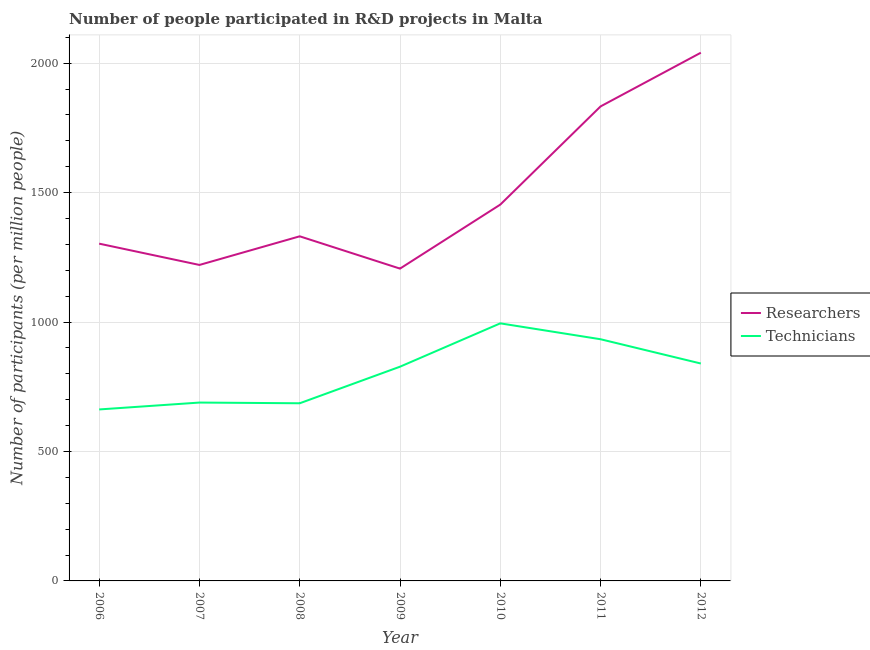Does the line corresponding to number of researchers intersect with the line corresponding to number of technicians?
Your answer should be compact. No. What is the number of technicians in 2010?
Your response must be concise. 994.99. Across all years, what is the maximum number of researchers?
Make the answer very short. 2040.44. Across all years, what is the minimum number of researchers?
Offer a very short reply. 1206.42. In which year was the number of technicians maximum?
Keep it short and to the point. 2010. In which year was the number of technicians minimum?
Offer a very short reply. 2006. What is the total number of researchers in the graph?
Give a very brief answer. 1.04e+04. What is the difference between the number of technicians in 2010 and that in 2012?
Your answer should be very brief. 155.15. What is the difference between the number of technicians in 2012 and the number of researchers in 2009?
Make the answer very short. -366.58. What is the average number of technicians per year?
Keep it short and to the point. 804.8. In the year 2008, what is the difference between the number of researchers and number of technicians?
Your response must be concise. 644.98. What is the ratio of the number of technicians in 2007 to that in 2011?
Offer a very short reply. 0.74. Is the number of researchers in 2006 less than that in 2010?
Your answer should be compact. Yes. Is the difference between the number of technicians in 2007 and 2009 greater than the difference between the number of researchers in 2007 and 2009?
Your answer should be compact. No. What is the difference between the highest and the second highest number of researchers?
Keep it short and to the point. 207.44. What is the difference between the highest and the lowest number of researchers?
Give a very brief answer. 834.02. Is the number of researchers strictly greater than the number of technicians over the years?
Provide a short and direct response. Yes. How many years are there in the graph?
Provide a succinct answer. 7. Are the values on the major ticks of Y-axis written in scientific E-notation?
Ensure brevity in your answer.  No. Does the graph contain any zero values?
Make the answer very short. No. Where does the legend appear in the graph?
Provide a succinct answer. Center right. What is the title of the graph?
Your answer should be compact. Number of people participated in R&D projects in Malta. Does "Quality of trade" appear as one of the legend labels in the graph?
Keep it short and to the point. No. What is the label or title of the X-axis?
Provide a short and direct response. Year. What is the label or title of the Y-axis?
Give a very brief answer. Number of participants (per million people). What is the Number of participants (per million people) in Researchers in 2006?
Offer a very short reply. 1302.85. What is the Number of participants (per million people) of Technicians in 2006?
Offer a very short reply. 662.41. What is the Number of participants (per million people) in Researchers in 2007?
Give a very brief answer. 1220.61. What is the Number of participants (per million people) of Technicians in 2007?
Your response must be concise. 688.99. What is the Number of participants (per million people) in Researchers in 2008?
Your response must be concise. 1331.23. What is the Number of participants (per million people) of Technicians in 2008?
Offer a terse response. 686.24. What is the Number of participants (per million people) of Researchers in 2009?
Provide a short and direct response. 1206.42. What is the Number of participants (per million people) of Technicians in 2009?
Give a very brief answer. 827.54. What is the Number of participants (per million people) in Researchers in 2010?
Offer a terse response. 1453.66. What is the Number of participants (per million people) in Technicians in 2010?
Provide a succinct answer. 994.99. What is the Number of participants (per million people) of Researchers in 2011?
Ensure brevity in your answer.  1833. What is the Number of participants (per million people) of Technicians in 2011?
Keep it short and to the point. 933.6. What is the Number of participants (per million people) in Researchers in 2012?
Make the answer very short. 2040.44. What is the Number of participants (per million people) of Technicians in 2012?
Offer a very short reply. 839.84. Across all years, what is the maximum Number of participants (per million people) in Researchers?
Your answer should be compact. 2040.44. Across all years, what is the maximum Number of participants (per million people) of Technicians?
Provide a short and direct response. 994.99. Across all years, what is the minimum Number of participants (per million people) of Researchers?
Make the answer very short. 1206.42. Across all years, what is the minimum Number of participants (per million people) of Technicians?
Offer a terse response. 662.41. What is the total Number of participants (per million people) in Researchers in the graph?
Provide a short and direct response. 1.04e+04. What is the total Number of participants (per million people) of Technicians in the graph?
Your response must be concise. 5633.61. What is the difference between the Number of participants (per million people) of Researchers in 2006 and that in 2007?
Offer a very short reply. 82.24. What is the difference between the Number of participants (per million people) in Technicians in 2006 and that in 2007?
Ensure brevity in your answer.  -26.58. What is the difference between the Number of participants (per million people) of Researchers in 2006 and that in 2008?
Your answer should be very brief. -28.38. What is the difference between the Number of participants (per million people) in Technicians in 2006 and that in 2008?
Keep it short and to the point. -23.84. What is the difference between the Number of participants (per million people) of Researchers in 2006 and that in 2009?
Provide a succinct answer. 96.43. What is the difference between the Number of participants (per million people) in Technicians in 2006 and that in 2009?
Give a very brief answer. -165.14. What is the difference between the Number of participants (per million people) in Researchers in 2006 and that in 2010?
Ensure brevity in your answer.  -150.81. What is the difference between the Number of participants (per million people) of Technicians in 2006 and that in 2010?
Your response must be concise. -332.58. What is the difference between the Number of participants (per million people) in Researchers in 2006 and that in 2011?
Give a very brief answer. -530.15. What is the difference between the Number of participants (per million people) of Technicians in 2006 and that in 2011?
Your answer should be compact. -271.19. What is the difference between the Number of participants (per million people) of Researchers in 2006 and that in 2012?
Give a very brief answer. -737.59. What is the difference between the Number of participants (per million people) of Technicians in 2006 and that in 2012?
Your response must be concise. -177.43. What is the difference between the Number of participants (per million people) of Researchers in 2007 and that in 2008?
Keep it short and to the point. -110.61. What is the difference between the Number of participants (per million people) in Technicians in 2007 and that in 2008?
Offer a terse response. 2.75. What is the difference between the Number of participants (per million people) of Researchers in 2007 and that in 2009?
Your answer should be compact. 14.19. What is the difference between the Number of participants (per million people) of Technicians in 2007 and that in 2009?
Provide a succinct answer. -138.55. What is the difference between the Number of participants (per million people) of Researchers in 2007 and that in 2010?
Your answer should be compact. -233.04. What is the difference between the Number of participants (per million people) of Technicians in 2007 and that in 2010?
Your answer should be very brief. -306. What is the difference between the Number of participants (per million people) of Researchers in 2007 and that in 2011?
Provide a short and direct response. -612.39. What is the difference between the Number of participants (per million people) in Technicians in 2007 and that in 2011?
Provide a short and direct response. -244.61. What is the difference between the Number of participants (per million people) in Researchers in 2007 and that in 2012?
Ensure brevity in your answer.  -819.83. What is the difference between the Number of participants (per million people) in Technicians in 2007 and that in 2012?
Your response must be concise. -150.85. What is the difference between the Number of participants (per million people) in Researchers in 2008 and that in 2009?
Your answer should be compact. 124.8. What is the difference between the Number of participants (per million people) of Technicians in 2008 and that in 2009?
Your answer should be compact. -141.3. What is the difference between the Number of participants (per million people) in Researchers in 2008 and that in 2010?
Keep it short and to the point. -122.43. What is the difference between the Number of participants (per million people) in Technicians in 2008 and that in 2010?
Your answer should be very brief. -308.74. What is the difference between the Number of participants (per million people) of Researchers in 2008 and that in 2011?
Make the answer very short. -501.77. What is the difference between the Number of participants (per million people) of Technicians in 2008 and that in 2011?
Provide a succinct answer. -247.35. What is the difference between the Number of participants (per million people) of Researchers in 2008 and that in 2012?
Ensure brevity in your answer.  -709.22. What is the difference between the Number of participants (per million people) of Technicians in 2008 and that in 2012?
Keep it short and to the point. -153.59. What is the difference between the Number of participants (per million people) of Researchers in 2009 and that in 2010?
Ensure brevity in your answer.  -247.23. What is the difference between the Number of participants (per million people) of Technicians in 2009 and that in 2010?
Provide a short and direct response. -167.45. What is the difference between the Number of participants (per million people) of Researchers in 2009 and that in 2011?
Keep it short and to the point. -626.58. What is the difference between the Number of participants (per million people) in Technicians in 2009 and that in 2011?
Ensure brevity in your answer.  -106.06. What is the difference between the Number of participants (per million people) of Researchers in 2009 and that in 2012?
Your response must be concise. -834.02. What is the difference between the Number of participants (per million people) of Technicians in 2009 and that in 2012?
Offer a terse response. -12.3. What is the difference between the Number of participants (per million people) of Researchers in 2010 and that in 2011?
Offer a terse response. -379.34. What is the difference between the Number of participants (per million people) of Technicians in 2010 and that in 2011?
Make the answer very short. 61.39. What is the difference between the Number of participants (per million people) of Researchers in 2010 and that in 2012?
Your answer should be compact. -586.79. What is the difference between the Number of participants (per million people) in Technicians in 2010 and that in 2012?
Give a very brief answer. 155.15. What is the difference between the Number of participants (per million people) of Researchers in 2011 and that in 2012?
Provide a short and direct response. -207.44. What is the difference between the Number of participants (per million people) of Technicians in 2011 and that in 2012?
Your response must be concise. 93.76. What is the difference between the Number of participants (per million people) in Researchers in 2006 and the Number of participants (per million people) in Technicians in 2007?
Offer a terse response. 613.86. What is the difference between the Number of participants (per million people) of Researchers in 2006 and the Number of participants (per million people) of Technicians in 2008?
Provide a short and direct response. 616.61. What is the difference between the Number of participants (per million people) in Researchers in 2006 and the Number of participants (per million people) in Technicians in 2009?
Offer a very short reply. 475.31. What is the difference between the Number of participants (per million people) of Researchers in 2006 and the Number of participants (per million people) of Technicians in 2010?
Offer a terse response. 307.86. What is the difference between the Number of participants (per million people) of Researchers in 2006 and the Number of participants (per million people) of Technicians in 2011?
Your response must be concise. 369.25. What is the difference between the Number of participants (per million people) in Researchers in 2006 and the Number of participants (per million people) in Technicians in 2012?
Give a very brief answer. 463.01. What is the difference between the Number of participants (per million people) in Researchers in 2007 and the Number of participants (per million people) in Technicians in 2008?
Make the answer very short. 534.37. What is the difference between the Number of participants (per million people) in Researchers in 2007 and the Number of participants (per million people) in Technicians in 2009?
Your response must be concise. 393.07. What is the difference between the Number of participants (per million people) in Researchers in 2007 and the Number of participants (per million people) in Technicians in 2010?
Your answer should be compact. 225.62. What is the difference between the Number of participants (per million people) of Researchers in 2007 and the Number of participants (per million people) of Technicians in 2011?
Ensure brevity in your answer.  287.01. What is the difference between the Number of participants (per million people) in Researchers in 2007 and the Number of participants (per million people) in Technicians in 2012?
Your answer should be very brief. 380.78. What is the difference between the Number of participants (per million people) in Researchers in 2008 and the Number of participants (per million people) in Technicians in 2009?
Keep it short and to the point. 503.69. What is the difference between the Number of participants (per million people) in Researchers in 2008 and the Number of participants (per million people) in Technicians in 2010?
Provide a short and direct response. 336.24. What is the difference between the Number of participants (per million people) of Researchers in 2008 and the Number of participants (per million people) of Technicians in 2011?
Provide a short and direct response. 397.63. What is the difference between the Number of participants (per million people) in Researchers in 2008 and the Number of participants (per million people) in Technicians in 2012?
Your response must be concise. 491.39. What is the difference between the Number of participants (per million people) of Researchers in 2009 and the Number of participants (per million people) of Technicians in 2010?
Your answer should be compact. 211.43. What is the difference between the Number of participants (per million people) of Researchers in 2009 and the Number of participants (per million people) of Technicians in 2011?
Your answer should be very brief. 272.82. What is the difference between the Number of participants (per million people) of Researchers in 2009 and the Number of participants (per million people) of Technicians in 2012?
Your response must be concise. 366.58. What is the difference between the Number of participants (per million people) of Researchers in 2010 and the Number of participants (per million people) of Technicians in 2011?
Offer a terse response. 520.06. What is the difference between the Number of participants (per million people) of Researchers in 2010 and the Number of participants (per million people) of Technicians in 2012?
Give a very brief answer. 613.82. What is the difference between the Number of participants (per million people) of Researchers in 2011 and the Number of participants (per million people) of Technicians in 2012?
Your response must be concise. 993.16. What is the average Number of participants (per million people) of Researchers per year?
Keep it short and to the point. 1484.03. What is the average Number of participants (per million people) in Technicians per year?
Give a very brief answer. 804.8. In the year 2006, what is the difference between the Number of participants (per million people) of Researchers and Number of participants (per million people) of Technicians?
Give a very brief answer. 640.45. In the year 2007, what is the difference between the Number of participants (per million people) of Researchers and Number of participants (per million people) of Technicians?
Your response must be concise. 531.62. In the year 2008, what is the difference between the Number of participants (per million people) in Researchers and Number of participants (per million people) in Technicians?
Offer a terse response. 644.98. In the year 2009, what is the difference between the Number of participants (per million people) of Researchers and Number of participants (per million people) of Technicians?
Make the answer very short. 378.88. In the year 2010, what is the difference between the Number of participants (per million people) of Researchers and Number of participants (per million people) of Technicians?
Your response must be concise. 458.67. In the year 2011, what is the difference between the Number of participants (per million people) of Researchers and Number of participants (per million people) of Technicians?
Your answer should be very brief. 899.4. In the year 2012, what is the difference between the Number of participants (per million people) of Researchers and Number of participants (per million people) of Technicians?
Your answer should be compact. 1200.61. What is the ratio of the Number of participants (per million people) of Researchers in 2006 to that in 2007?
Your answer should be compact. 1.07. What is the ratio of the Number of participants (per million people) in Technicians in 2006 to that in 2007?
Your response must be concise. 0.96. What is the ratio of the Number of participants (per million people) of Researchers in 2006 to that in 2008?
Your response must be concise. 0.98. What is the ratio of the Number of participants (per million people) in Technicians in 2006 to that in 2008?
Give a very brief answer. 0.97. What is the ratio of the Number of participants (per million people) in Researchers in 2006 to that in 2009?
Make the answer very short. 1.08. What is the ratio of the Number of participants (per million people) in Technicians in 2006 to that in 2009?
Offer a very short reply. 0.8. What is the ratio of the Number of participants (per million people) in Researchers in 2006 to that in 2010?
Make the answer very short. 0.9. What is the ratio of the Number of participants (per million people) in Technicians in 2006 to that in 2010?
Provide a succinct answer. 0.67. What is the ratio of the Number of participants (per million people) in Researchers in 2006 to that in 2011?
Your answer should be very brief. 0.71. What is the ratio of the Number of participants (per million people) of Technicians in 2006 to that in 2011?
Keep it short and to the point. 0.71. What is the ratio of the Number of participants (per million people) in Researchers in 2006 to that in 2012?
Your answer should be compact. 0.64. What is the ratio of the Number of participants (per million people) of Technicians in 2006 to that in 2012?
Keep it short and to the point. 0.79. What is the ratio of the Number of participants (per million people) in Researchers in 2007 to that in 2008?
Make the answer very short. 0.92. What is the ratio of the Number of participants (per million people) in Researchers in 2007 to that in 2009?
Give a very brief answer. 1.01. What is the ratio of the Number of participants (per million people) in Technicians in 2007 to that in 2009?
Offer a terse response. 0.83. What is the ratio of the Number of participants (per million people) of Researchers in 2007 to that in 2010?
Ensure brevity in your answer.  0.84. What is the ratio of the Number of participants (per million people) of Technicians in 2007 to that in 2010?
Give a very brief answer. 0.69. What is the ratio of the Number of participants (per million people) in Researchers in 2007 to that in 2011?
Keep it short and to the point. 0.67. What is the ratio of the Number of participants (per million people) of Technicians in 2007 to that in 2011?
Keep it short and to the point. 0.74. What is the ratio of the Number of participants (per million people) in Researchers in 2007 to that in 2012?
Provide a succinct answer. 0.6. What is the ratio of the Number of participants (per million people) of Technicians in 2007 to that in 2012?
Give a very brief answer. 0.82. What is the ratio of the Number of participants (per million people) of Researchers in 2008 to that in 2009?
Provide a short and direct response. 1.1. What is the ratio of the Number of participants (per million people) of Technicians in 2008 to that in 2009?
Keep it short and to the point. 0.83. What is the ratio of the Number of participants (per million people) of Researchers in 2008 to that in 2010?
Keep it short and to the point. 0.92. What is the ratio of the Number of participants (per million people) of Technicians in 2008 to that in 2010?
Offer a very short reply. 0.69. What is the ratio of the Number of participants (per million people) in Researchers in 2008 to that in 2011?
Give a very brief answer. 0.73. What is the ratio of the Number of participants (per million people) in Technicians in 2008 to that in 2011?
Keep it short and to the point. 0.74. What is the ratio of the Number of participants (per million people) of Researchers in 2008 to that in 2012?
Keep it short and to the point. 0.65. What is the ratio of the Number of participants (per million people) in Technicians in 2008 to that in 2012?
Make the answer very short. 0.82. What is the ratio of the Number of participants (per million people) of Researchers in 2009 to that in 2010?
Offer a terse response. 0.83. What is the ratio of the Number of participants (per million people) of Technicians in 2009 to that in 2010?
Ensure brevity in your answer.  0.83. What is the ratio of the Number of participants (per million people) in Researchers in 2009 to that in 2011?
Give a very brief answer. 0.66. What is the ratio of the Number of participants (per million people) in Technicians in 2009 to that in 2011?
Make the answer very short. 0.89. What is the ratio of the Number of participants (per million people) in Researchers in 2009 to that in 2012?
Offer a very short reply. 0.59. What is the ratio of the Number of participants (per million people) in Technicians in 2009 to that in 2012?
Make the answer very short. 0.99. What is the ratio of the Number of participants (per million people) in Researchers in 2010 to that in 2011?
Offer a terse response. 0.79. What is the ratio of the Number of participants (per million people) of Technicians in 2010 to that in 2011?
Provide a short and direct response. 1.07. What is the ratio of the Number of participants (per million people) in Researchers in 2010 to that in 2012?
Ensure brevity in your answer.  0.71. What is the ratio of the Number of participants (per million people) of Technicians in 2010 to that in 2012?
Your answer should be compact. 1.18. What is the ratio of the Number of participants (per million people) in Researchers in 2011 to that in 2012?
Offer a very short reply. 0.9. What is the ratio of the Number of participants (per million people) in Technicians in 2011 to that in 2012?
Ensure brevity in your answer.  1.11. What is the difference between the highest and the second highest Number of participants (per million people) of Researchers?
Make the answer very short. 207.44. What is the difference between the highest and the second highest Number of participants (per million people) in Technicians?
Give a very brief answer. 61.39. What is the difference between the highest and the lowest Number of participants (per million people) of Researchers?
Provide a succinct answer. 834.02. What is the difference between the highest and the lowest Number of participants (per million people) in Technicians?
Give a very brief answer. 332.58. 